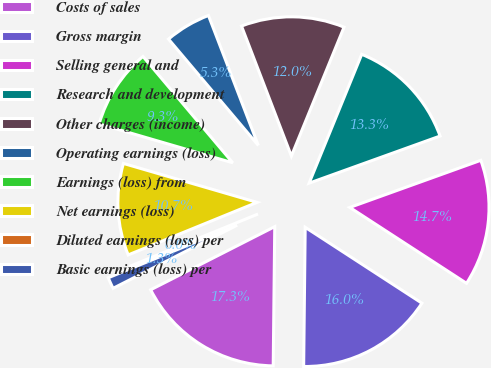Convert chart. <chart><loc_0><loc_0><loc_500><loc_500><pie_chart><fcel>Costs of sales<fcel>Gross margin<fcel>Selling general and<fcel>Research and development<fcel>Other charges (income)<fcel>Operating earnings (loss)<fcel>Earnings (loss) from<fcel>Net earnings (loss)<fcel>Diluted earnings (loss) per<fcel>Basic earnings (loss) per<nl><fcel>17.33%<fcel>16.0%<fcel>14.67%<fcel>13.33%<fcel>12.0%<fcel>5.33%<fcel>9.33%<fcel>10.67%<fcel>0.0%<fcel>1.33%<nl></chart> 